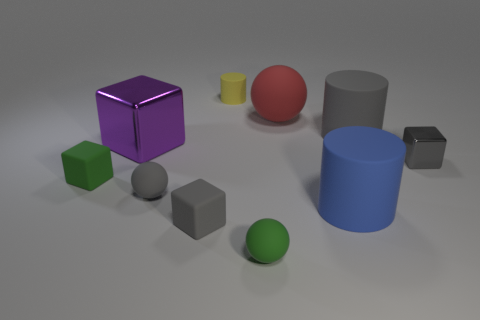Is the number of yellow things that are to the right of the yellow object greater than the number of tiny metallic things? Upon examining the image, it appears that there is only one yellow cylindrical object, and to its right, there are no other yellow objects. As for tiny metallic things, there is one small gray metallic cube. Therefore, the number of yellow things to the right of the yellow object is not greater than the number of tiny metallic things; in fact, both counts are equal at one each. 